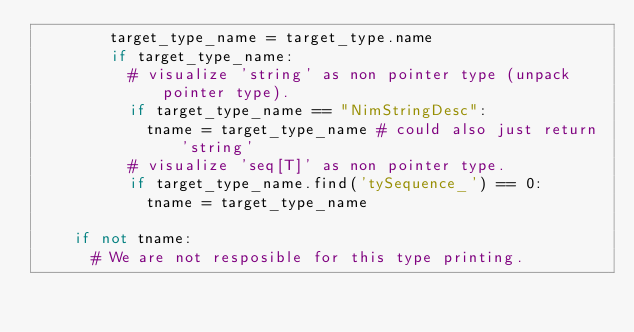Convert code to text. <code><loc_0><loc_0><loc_500><loc_500><_Python_>        target_type_name = target_type.name
        if target_type_name:
          # visualize 'string' as non pointer type (unpack pointer type).
          if target_type_name == "NimStringDesc":
            tname = target_type_name # could also just return 'string'
          # visualize 'seq[T]' as non pointer type.
          if target_type_name.find('tySequence_') == 0:
            tname = target_type_name

    if not tname:
      # We are not resposible for this type printing.</code> 